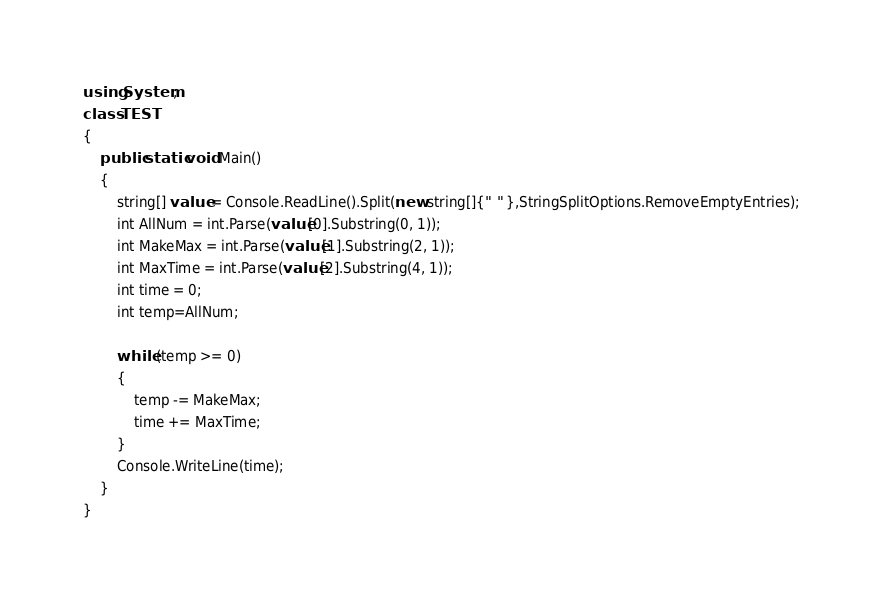<code> <loc_0><loc_0><loc_500><loc_500><_C#_>using System;
class TEST
{
    public static void Main()
    {
        string[] value = Console.ReadLine().Split(new string[]{" " },StringSplitOptions.RemoveEmptyEntries);
        int AllNum = int.Parse(value[0].Substring(0, 1));
        int MakeMax = int.Parse(value[1].Substring(2, 1));
        int MaxTime = int.Parse(value[2].Substring(4, 1));
        int time = 0;
        int temp=AllNum;
        
        while (temp >= 0)
        {
            temp -= MakeMax;
            time += MaxTime;
        }
        Console.WriteLine(time);
    }
}</code> 